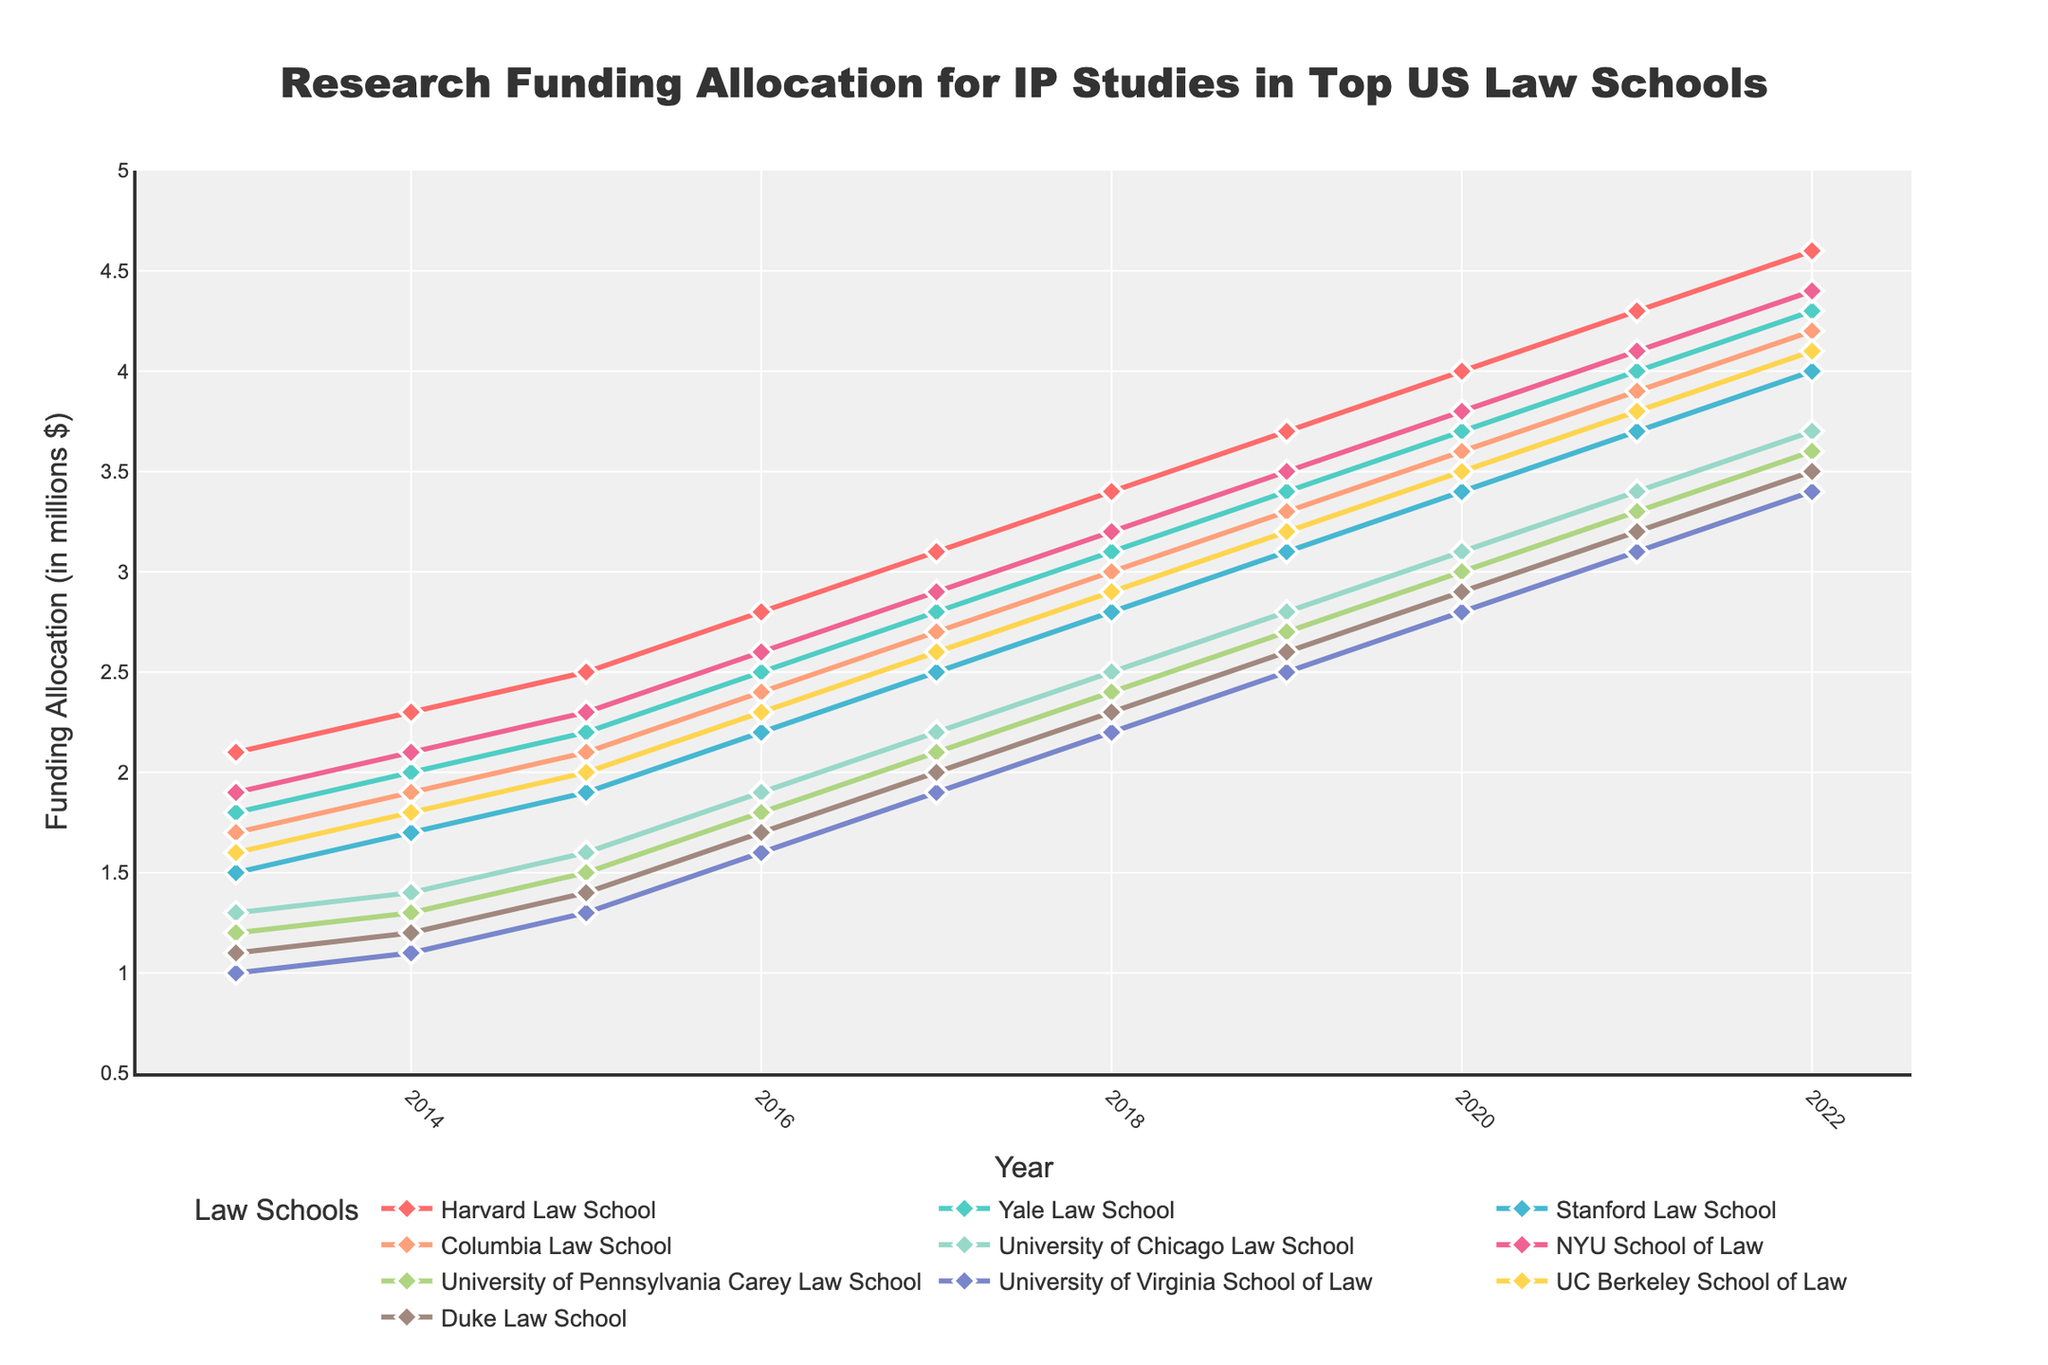What is the trend in research funding allocation for Harvard Law School from 2013 to 2022? To answer this, observe the trend line for Harvard Law School (colored in red) from 2013 to 2022. The line consistently increases each year, indicating a steady rise in funding allocation.
Answer: Increasing Which law school had the highest research funding allocation in 2019? Look for the highest point among all the schools for the year 2019. Harvard Law School has the highest funding, indicated by its position at the top of the 2019 data points.
Answer: Harvard Law School Compare the funding increase between Stanford Law School and NYU School of Law from 2013 to 2022. Which school had a greater increase? Calculate the difference in funding between 2013 and 2022 for both schools. For Stanford Law School, it's (4.0 - 1.5) = 2.5 million dollars, and for NYU School of Law, it's (4.4 - 1.9) = 2.5 million dollars. Since both had the same increase, neither had a greater increase.
Answer: Same increase Which law schools had funding allocations that surpassed the 3 million mark in 2020? Observe the 2020 data points and identify which schools had funding allocations over 3 million dollars in that year. Harvard, Yale, Stanford, Columbia, University of Chicago, NYU, and Berkeley all surpassed 3 million.
Answer: Harvard, Yale, Stanford, Columbia, University of Chicago, NYU, Berkeley What is the average funding allocation for Yale Law School from 2013 to 2022? Sum the funding values for Yale Law School from each year from 2013 to 2022 and divide by the number of years. The sum is (1.8 + 2.0 + 2.2 + 2.5 + 2.8 + 3.1 + 3.4 + 3.7 + 4.0 + 4.3) = 30.8, and there are 10 years. So, 30.8 / 10 = 3.08 million dollars.
Answer: 3.08 Between 2015 and 2017, which law school saw the most significant funding increase? Calculate the increase from 2015 to 2017 for each school. Harvard: (3.1 - 2.5) = 0.6, Yale: (2.8 - 2.2) = 0.6, Stanford: (2.5 - 1.9) = 0.6, Columbia: (2.7 - 2.1) = 0.6, University of Chicago: (2.2 - 1.6) = 0.6, NYU: (2.9 - 2.3) = 0.6, Penn: (2.1 - 1.5) = 0.6, Virginia: (1.9 - 1.3) = 0.6, Berkeley: (2.6 - 2.0) = 0.6, Duke: (2.0 - 1.4) = 0.6. All schools saw the same increase of 0.6 million dollars.
Answer: All schools had the same increase What color represents the funding allocation for UC Berkeley School of Law, and how does its funding trend compare to Duke Law School? The UC Berkeley plot is colored in a light blue hue, and it shows a consistent upward trend from 2013 to 2022. Duke Law School's plot is brown and also shows an upward trend, but Berkeley's funding is consistently higher than Duke's.
Answer: Light blue, consistently higher Identify which year had the smallest gap in funding allocation between Harvard Law School and Yale Law School. Calculate the annual gaps between Harvard and Yale's funding and identify the year with the smallest difference: 2013 (2.1 - 1.8) = 0.3, 2014 (2.3 - 2.0) = 0.3, 2015 (2.5 - 2.2) = 0.3, 2016 (2.8 - 2.5) = 0.3, 2017 (3.1 - 2.8) = 0.3, 2018 (3.4 - 3.1) = 0.3, 2019 (3.7 - 3.4) = 0.3, 2020 (4.0 - 3.7) = 0.3, 2021 (4.3 - 4.0) = 0.3, 2022 (4.6 - 4.3) = 0.3. All years had the smallest gap of 0.3 million dollars.
Answer: All years had the same smallest gap of 0.3 